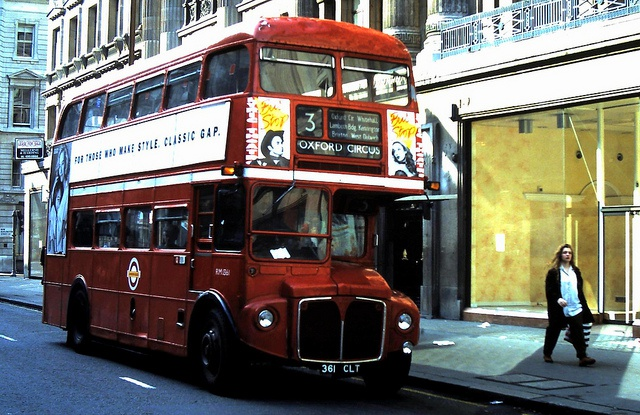Describe the objects in this image and their specific colors. I can see bus in lightblue, black, maroon, white, and gray tones, people in lightblue, black, white, and gray tones, and handbag in lightblue, black, gray, and darkgray tones in this image. 